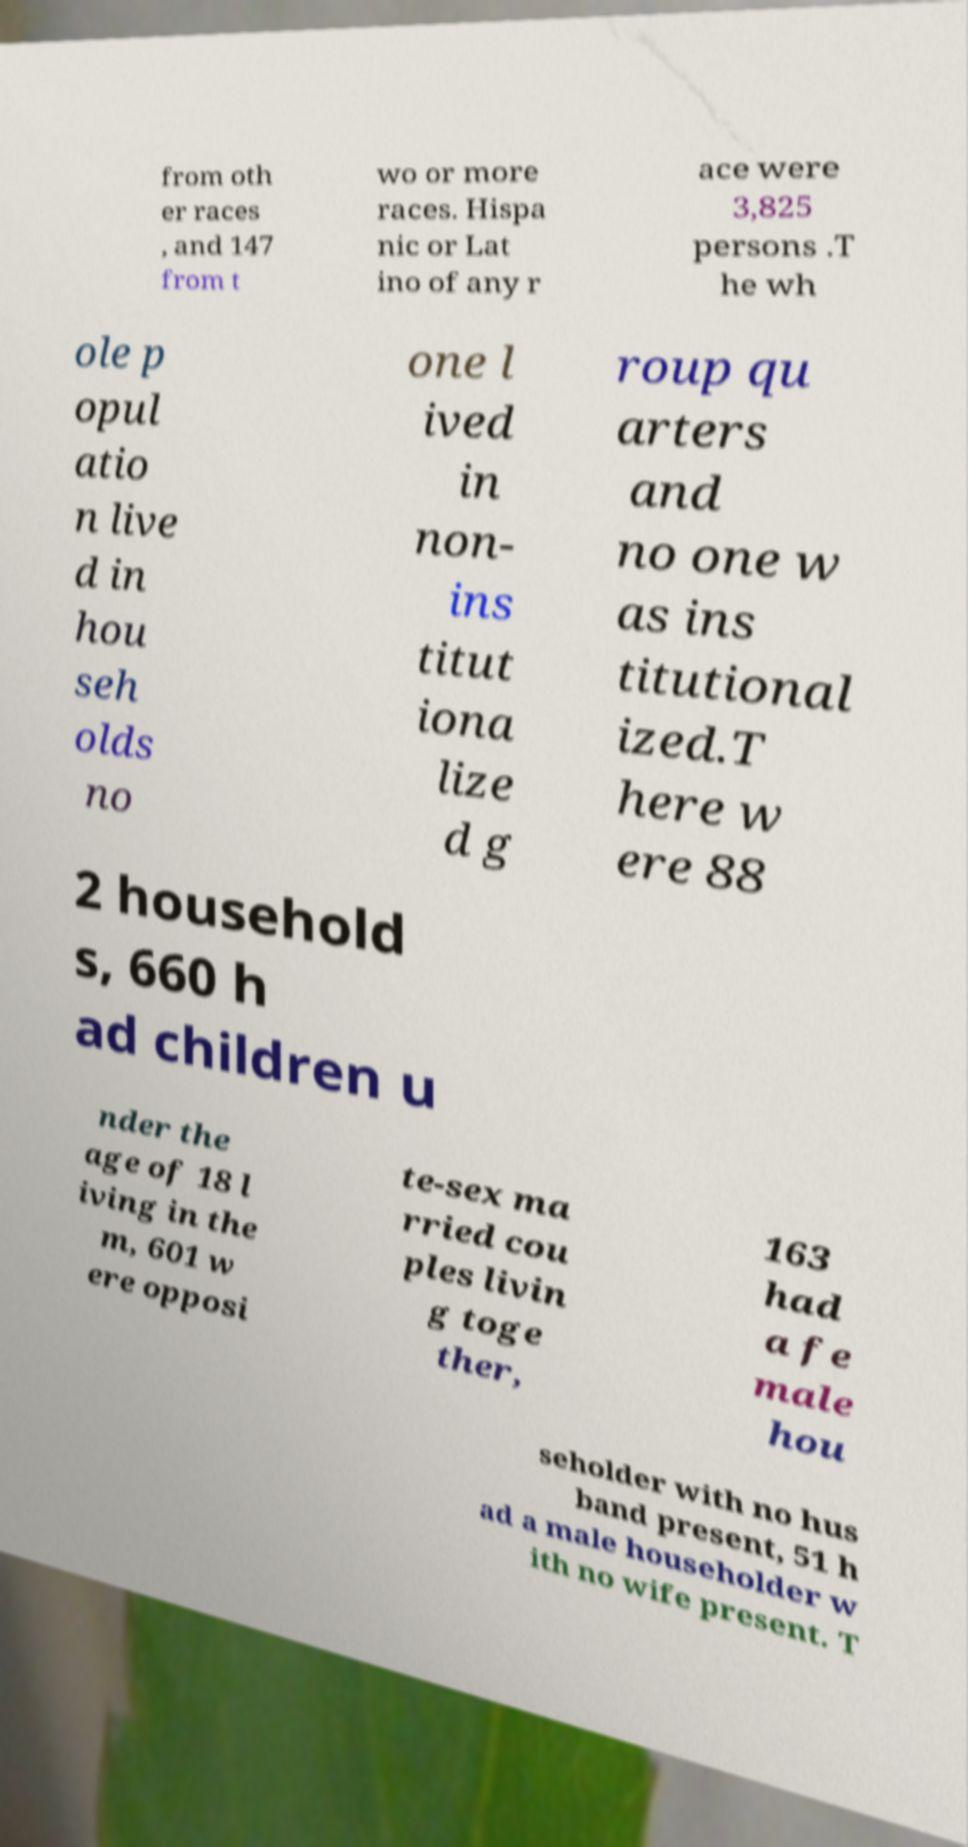What messages or text are displayed in this image? I need them in a readable, typed format. from oth er races , and 147 from t wo or more races. Hispa nic or Lat ino of any r ace were 3,825 persons .T he wh ole p opul atio n live d in hou seh olds no one l ived in non- ins titut iona lize d g roup qu arters and no one w as ins titutional ized.T here w ere 88 2 household s, 660 h ad children u nder the age of 18 l iving in the m, 601 w ere opposi te-sex ma rried cou ples livin g toge ther, 163 had a fe male hou seholder with no hus band present, 51 h ad a male householder w ith no wife present. T 